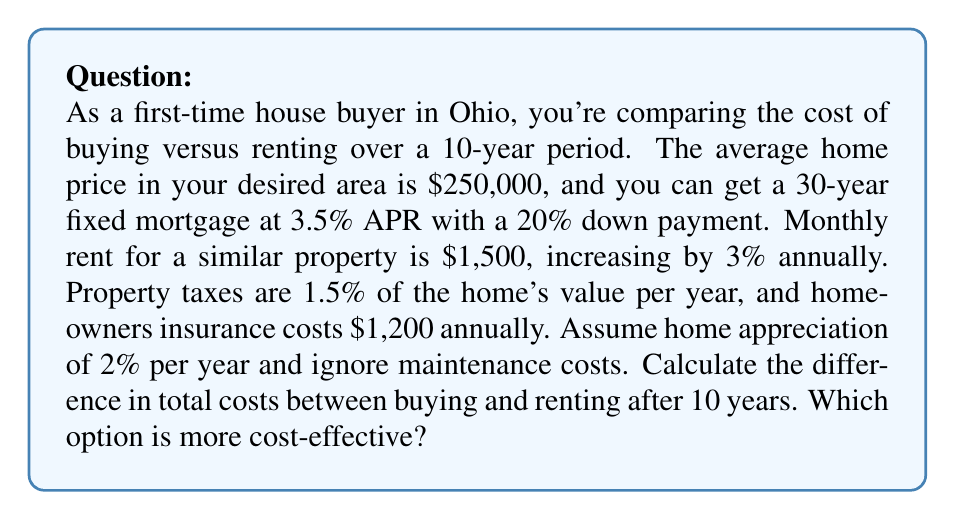Teach me how to tackle this problem. Let's break this down step-by-step:

1. Buying costs:
   a) Down payment: $250,000 * 20% = $50,000
   b) Mortgage: 
      Principal = $250,000 - $50,000 = $200,000
      Monthly payment = $898.09 (calculated using the mortgage formula)
      Total mortgage payments over 10 years = $898.09 * 12 * 10 = $107,770.80
   c) Property taxes over 10 years:
      $$\sum_{i=0}^9 250000 * (1.02)^i * 0.015 = $41,330.71$$
   d) Homeowners insurance: $1,200 * 10 = $12,000
   e) Home value after 10 years: $250,000 * (1.02)^10 = $304,717.46

   Total buying cost = $50,000 + $107,770.80 + $41,330.71 + $12,000 - ($304,717.46 - $250,000)
                     = $156,384.05

2. Renting costs:
   Monthly rent increases each year by 3%
   $$\sum_{i=0}^9 1500 * (1.03)^i * 12 = $206,921.94$$

3. Difference in total costs:
   $206,921.94 - $156,384.05 = $50,537.89

The buying option is more cost-effective over the 10-year period.
Answer: The difference in total costs between buying and renting after 10 years is $50,537.89, with buying being more cost-effective. 